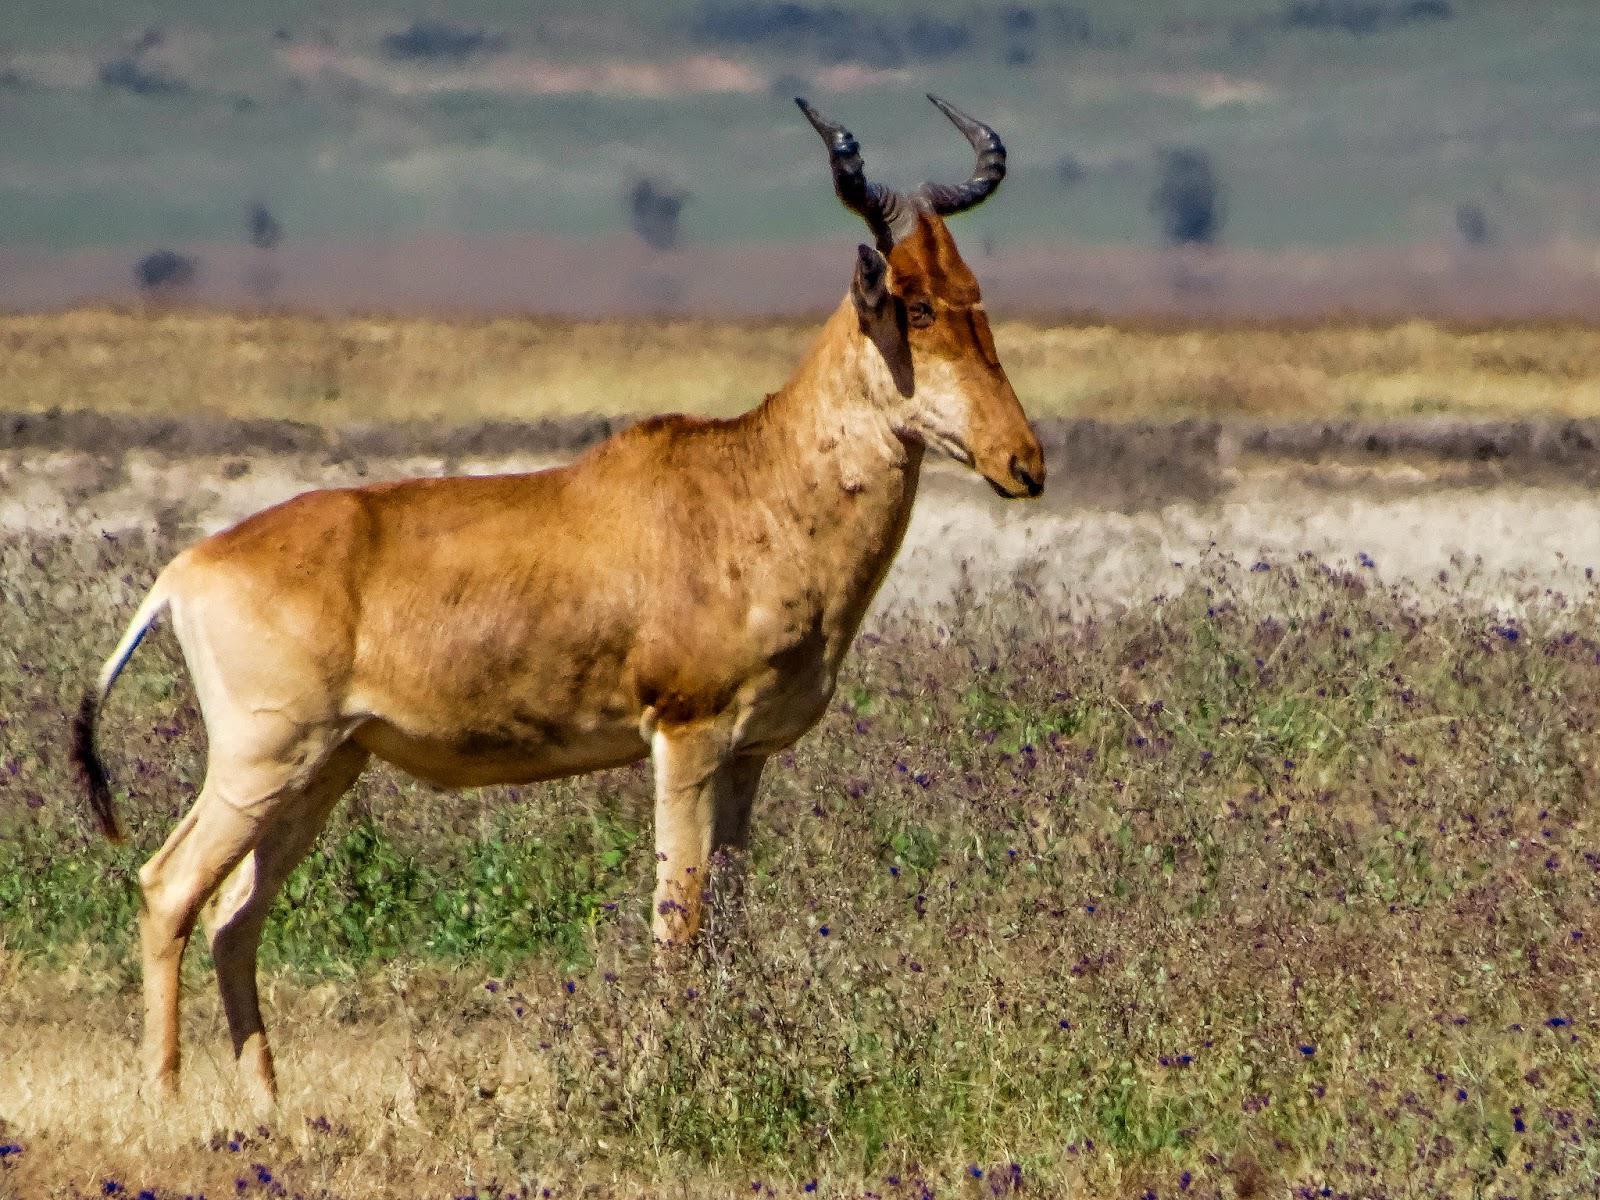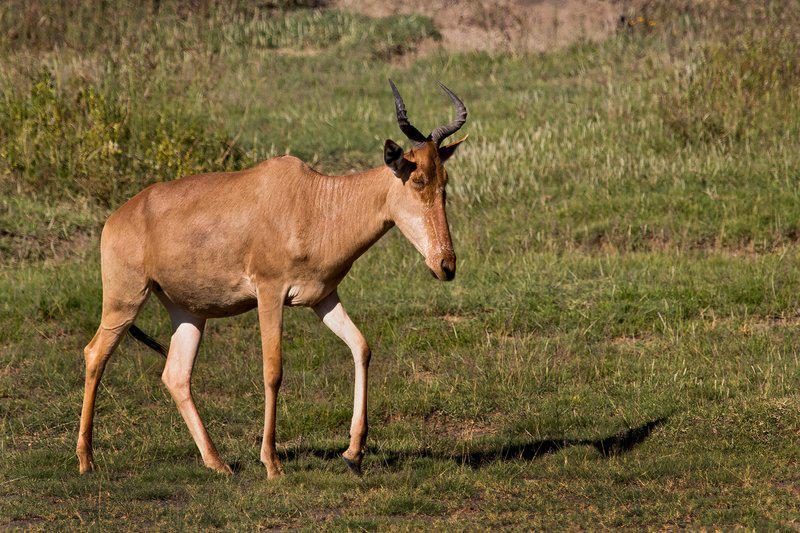The first image is the image on the left, the second image is the image on the right. Examine the images to the left and right. Is the description "Both images feature animals facing the same direction." accurate? Answer yes or no. Yes. 